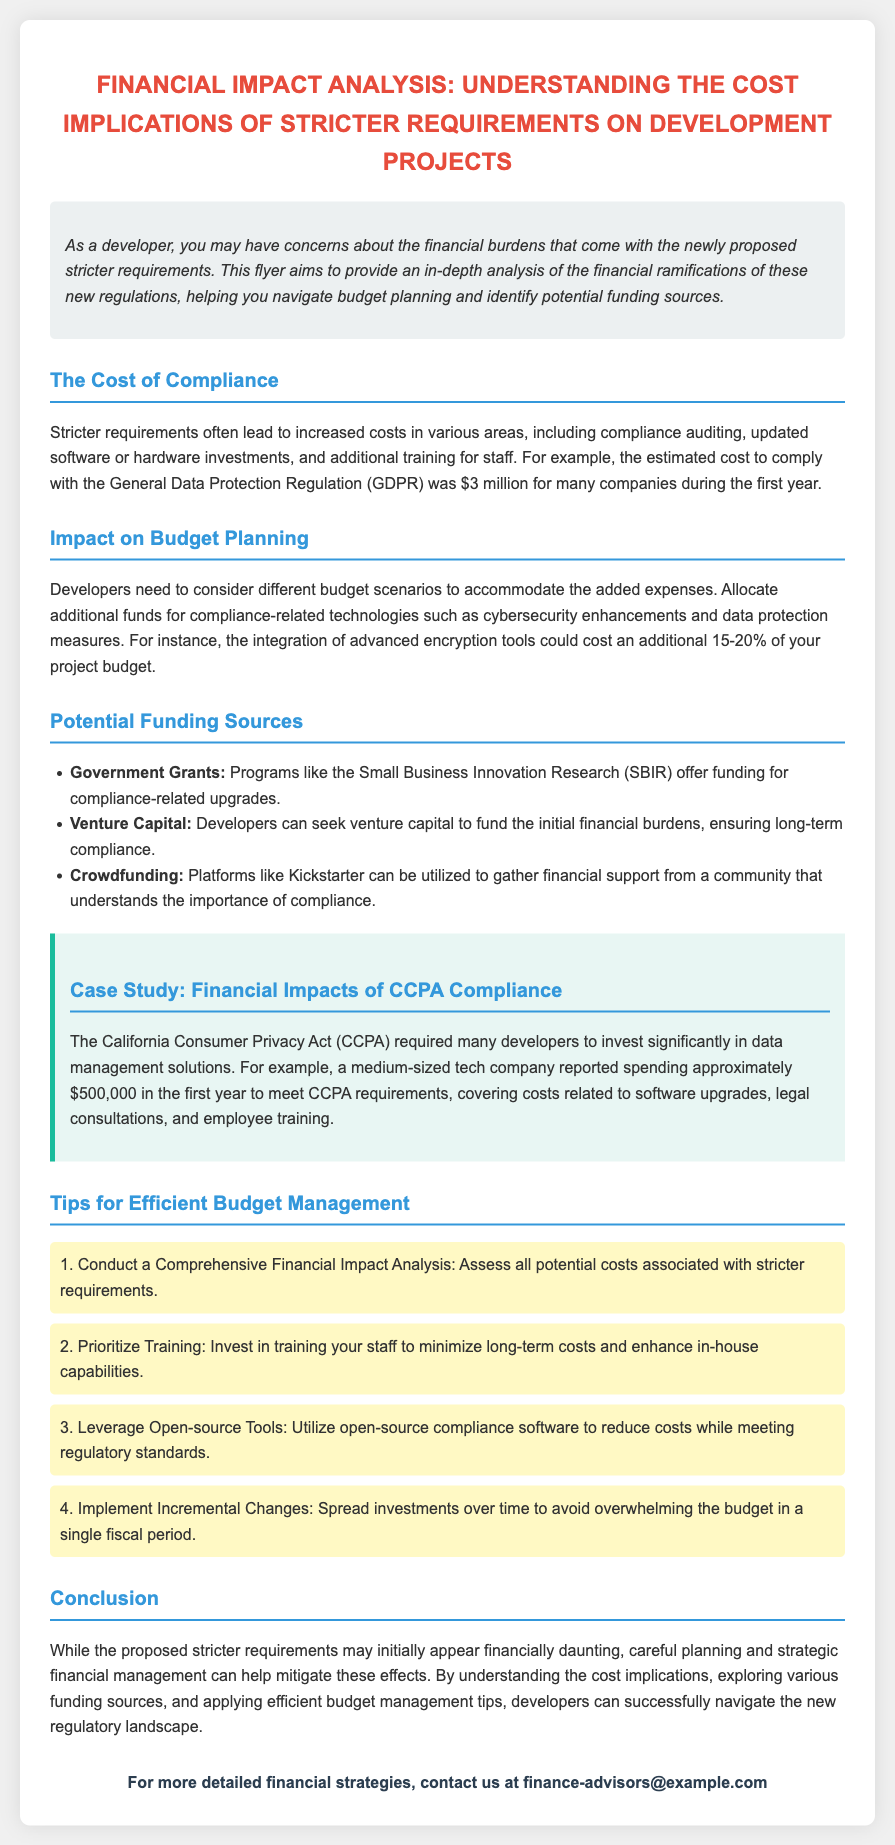What is the estimated cost to comply with GDPR? The estimated cost cited in the document for many companies during the first year was $3 million.
Answer: $3 million What percentage of the project budget could advanced encryption tools cost? The document states that the integration of advanced encryption tools could cost an additional 15-20% of the project budget.
Answer: 15-20% Which program offers government grants for compliance-related upgrades? The Small Business Innovation Research (SBIR) program is mentioned as offering funding for compliance-related upgrades.
Answer: SBIR How much did a medium-sized tech company spend to meet CCPA requirements? The case study indicates that a medium-sized tech company reported spending approximately $500,000 in the first year to meet CCPA requirements.
Answer: $500,000 What is the first tip for efficient budget management provided in the flyer? The first tip highlighted in the flyer is to "Conduct a Comprehensive Financial Impact Analysis".
Answer: Conduct a Comprehensive Financial Impact Analysis What is the color scheme mentioned for the case study section? The case study section is described to have a background color of #e8f6f3 and a border of #1abc9c.
Answer: #e8f6f3 and #1abc9c What is the contact email for detailed financial strategies? The flyer provides the contact email as finance-advisors@example.com.
Answer: finance-advisors@example.com What background color is used for the introduction section? The document states that the introduction section has a background color of #ecf0f1.
Answer: #ecf0f1 